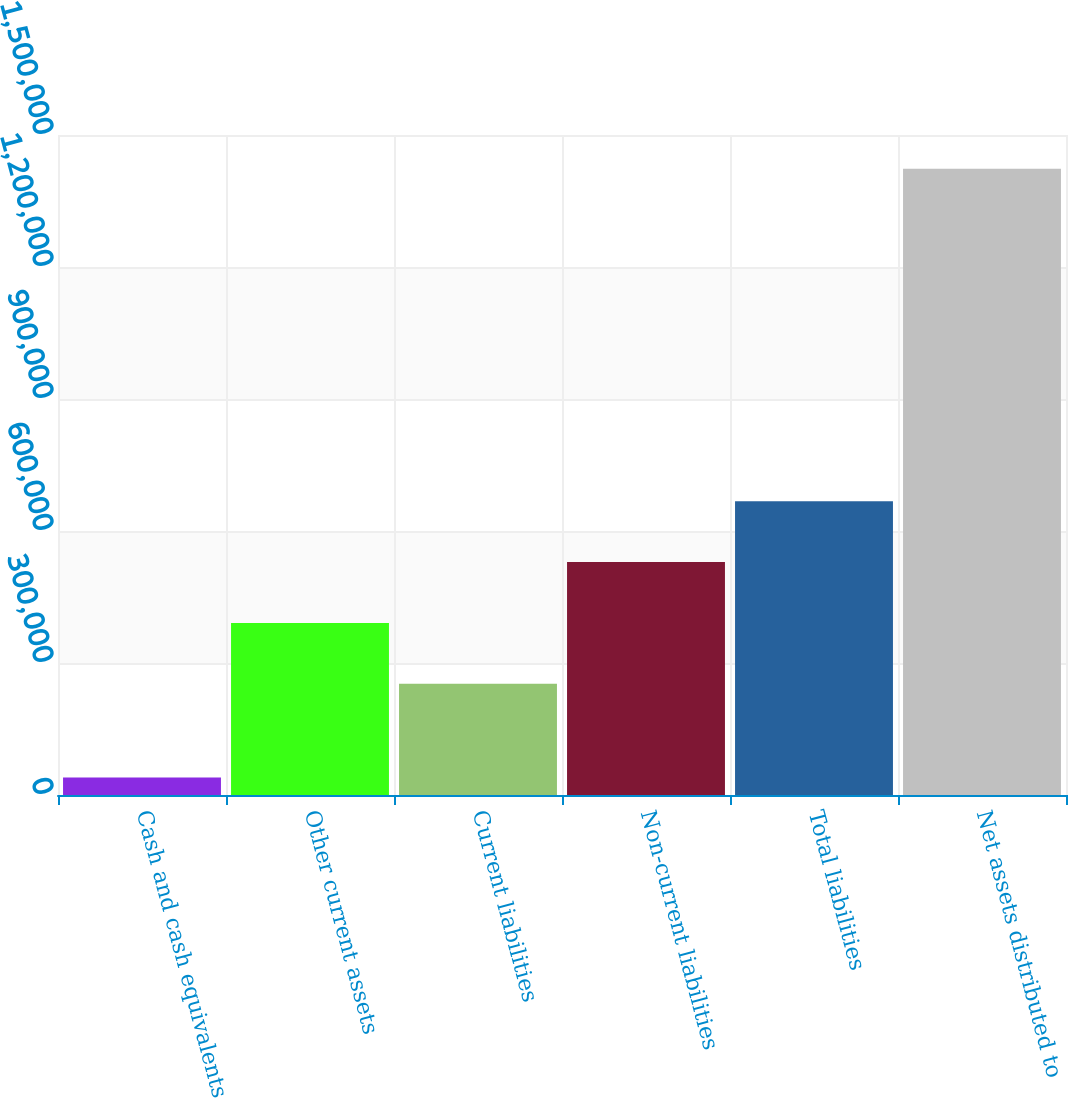Convert chart. <chart><loc_0><loc_0><loc_500><loc_500><bar_chart><fcel>Cash and cash equivalents<fcel>Other current assets<fcel>Current liabilities<fcel>Non-current liabilities<fcel>Total liabilities<fcel>Net assets distributed to<nl><fcel>40045<fcel>390988<fcel>252673<fcel>529303<fcel>667619<fcel>1.4232e+06<nl></chart> 